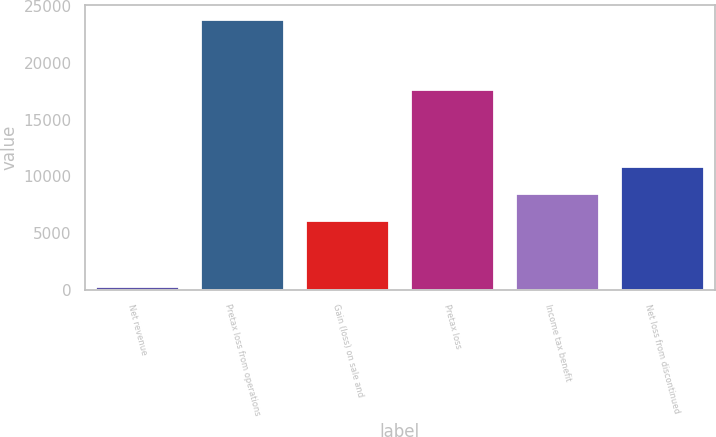Convert chart. <chart><loc_0><loc_0><loc_500><loc_500><bar_chart><fcel>Net revenue<fcel>Pretax loss from operations<fcel>Gain (loss) on sale and<fcel>Pretax loss<fcel>Income tax benefit<fcel>Net loss from discontinued<nl><fcel>372<fcel>23872<fcel>6194<fcel>17678<fcel>8544<fcel>10894<nl></chart> 